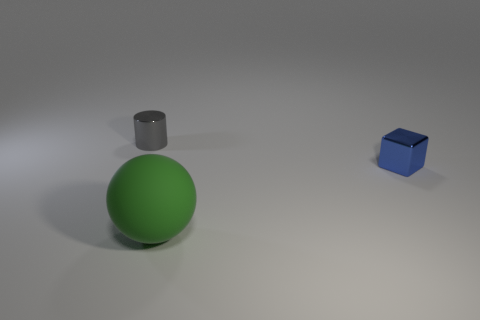Add 2 tiny blue blocks. How many objects exist? 5 Subtract 1 spheres. How many spheres are left? 0 Subtract all cyan balls. Subtract all yellow blocks. How many balls are left? 1 Subtract all purple balls. How many brown cubes are left? 0 Subtract all large rubber balls. Subtract all green matte spheres. How many objects are left? 1 Add 1 metal things. How many metal things are left? 3 Add 2 blue cubes. How many blue cubes exist? 3 Subtract 0 brown cylinders. How many objects are left? 3 Subtract all cylinders. How many objects are left? 2 